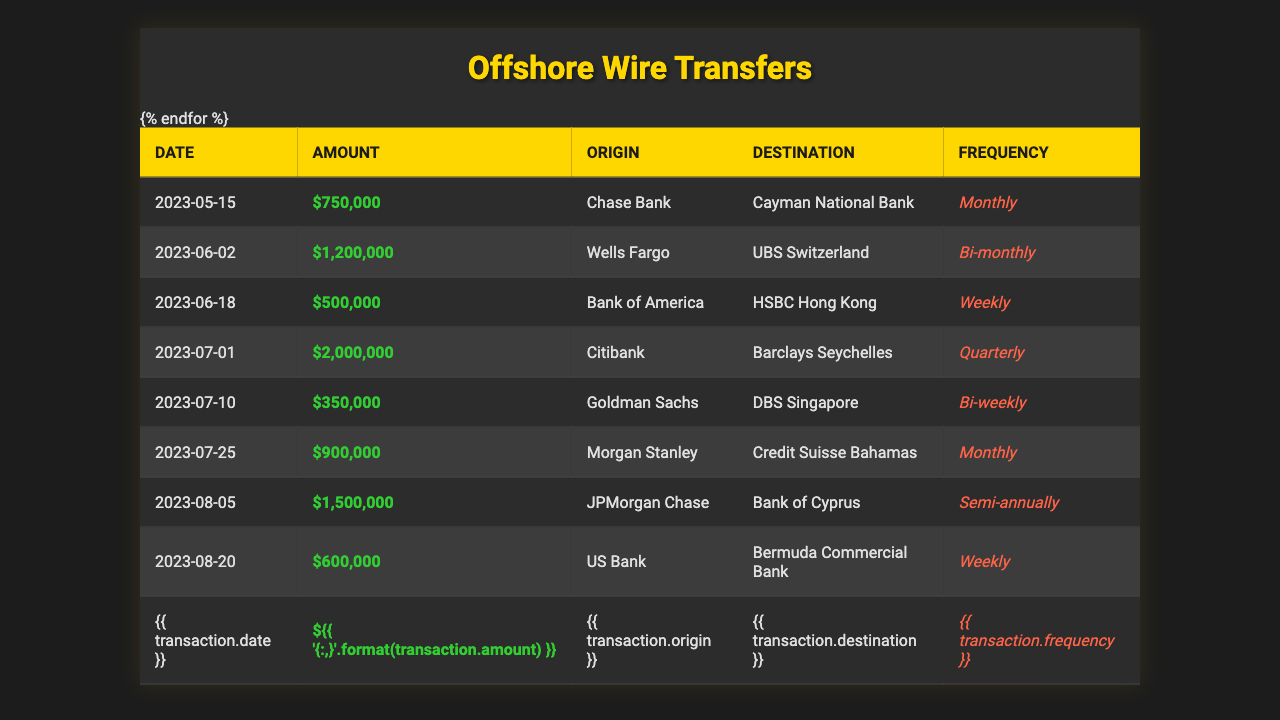What is the highest value wire transfer amount in the table? The table lists several wire transfer amounts. The highest amount mentioned is 2,000,000 on the date of July 1, 2023.
Answer: 2,000,000 How many wire transfers were sent in the month of July? The transactions in July are on July 1, July 10, and July 25. Counting these gives us a total of 3 wire transfers in July.
Answer: 3 Which bank initiated the transfer of 1,200,000? Looking at the table, the transfer of 1,200,000 is listed under the transaction on June 2, 2023, which originated from Wells Fargo.
Answer: Wells Fargo Is there any wire transfer that happens weekly? The table lists a transfer on June 18, 2023, and another one on August 20, 2023, both indicated as "Weekly" frequency. Thus, there are wire transfers that occur weekly.
Answer: Yes What is the total amount transferred in the month of August? The transactions in the month of August are on August 5 (1,500,000) and August 20 (600,000). Adding these gives us a total amount of 2,100,000 for August.
Answer: 2,100,000 Which bank made wire transfers to the highest number of different offshore accounts? Reviewing the table, Citibank on July 1, 2023, transferred to Barclays Seychelles, while other banks transferred to unique destinations as well. Citibank has made one transfer to one destination; every bank made transfers to different banks revealing no bank appears more than once in terms of unique destinations. Thus, all banks could be counted equally in this context with one unique transfer each.
Answer: All banks have unique destinations What is the average transfer amount for the transactions listed? There are 8 transactions listed with amounts: 750,000, 1,200,000, 500,000, 2,000,000, 350,000, 900,000, 1,500,000, and 600,000. The total amount is 750000 + 1200000 + 500000 + 2000000 + 350000 + 900000 + 1500000 + 600000 = 7,250,000. Dividing by 8 gives an average of 906,250.
Answer: 906,250 Does any bank show a "semi-annually" frequency in its transactions? Yes, the transaction on August 5, 2023, from JPMorgan Chase to Bank of Cyprus indicates a "Semi-annually" frequency.
Answer: Yes Which month had the highest total transfer amount based on the data provided? The total amounts for each month: May has 750,000; June has (1,200,000 + 500,000) = 1,700,000; July has (2,000,000 + 350,000 + 900,000) = 3,250,000; August has (1,500,000 + 600,000) = 2,100,000. The highest total is in July with 3,250,000.
Answer: July 